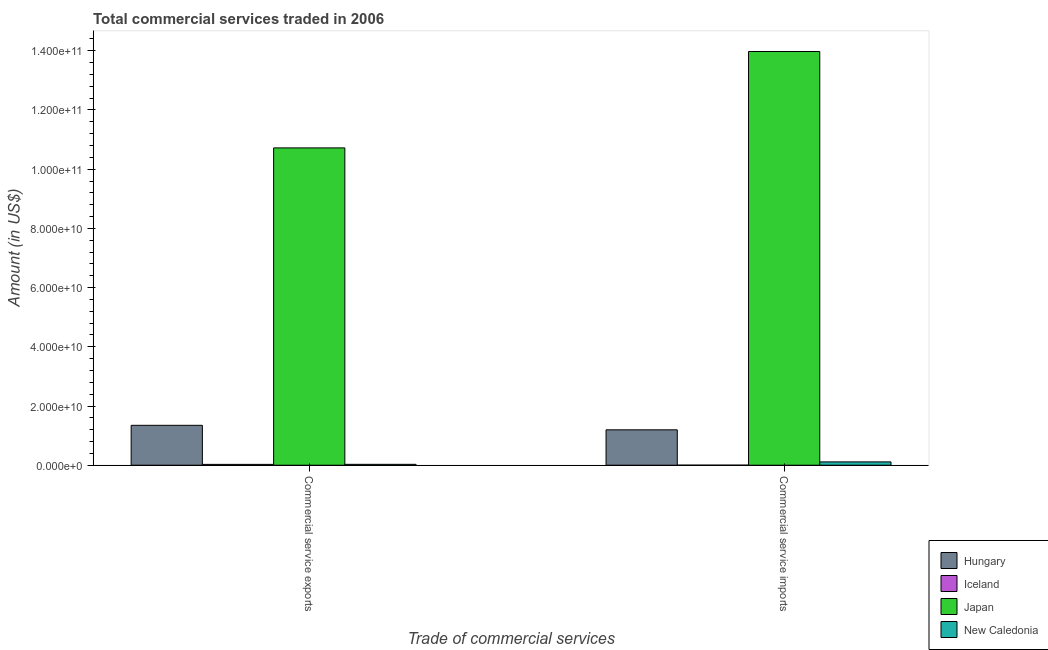How many bars are there on the 2nd tick from the left?
Provide a short and direct response. 4. What is the label of the 2nd group of bars from the left?
Keep it short and to the point. Commercial service imports. What is the amount of commercial service imports in Iceland?
Your answer should be very brief. 8.55e+06. Across all countries, what is the maximum amount of commercial service imports?
Provide a short and direct response. 1.40e+11. Across all countries, what is the minimum amount of commercial service imports?
Provide a succinct answer. 8.55e+06. What is the total amount of commercial service imports in the graph?
Offer a terse response. 1.53e+11. What is the difference between the amount of commercial service imports in Hungary and that in Iceland?
Your answer should be very brief. 1.19e+1. What is the difference between the amount of commercial service exports in Japan and the amount of commercial service imports in Hungary?
Keep it short and to the point. 9.52e+1. What is the average amount of commercial service exports per country?
Make the answer very short. 3.03e+1. What is the difference between the amount of commercial service exports and amount of commercial service imports in Japan?
Offer a terse response. -3.26e+1. In how many countries, is the amount of commercial service imports greater than 36000000000 US$?
Provide a succinct answer. 1. What is the ratio of the amount of commercial service exports in Iceland to that in New Caledonia?
Offer a terse response. 0.95. Is the amount of commercial service exports in New Caledonia less than that in Hungary?
Provide a short and direct response. Yes. In how many countries, is the amount of commercial service exports greater than the average amount of commercial service exports taken over all countries?
Provide a succinct answer. 1. What does the 3rd bar from the right in Commercial service imports represents?
Offer a very short reply. Iceland. How many countries are there in the graph?
Offer a terse response. 4. What is the difference between two consecutive major ticks on the Y-axis?
Your response must be concise. 2.00e+1. Are the values on the major ticks of Y-axis written in scientific E-notation?
Provide a short and direct response. Yes. Does the graph contain any zero values?
Your answer should be compact. No. How are the legend labels stacked?
Ensure brevity in your answer.  Vertical. What is the title of the graph?
Offer a terse response. Total commercial services traded in 2006. Does "Vanuatu" appear as one of the legend labels in the graph?
Your answer should be compact. No. What is the label or title of the X-axis?
Make the answer very short. Trade of commercial services. What is the label or title of the Y-axis?
Your answer should be very brief. Amount (in US$). What is the Amount (in US$) in Hungary in Commercial service exports?
Your answer should be very brief. 1.35e+1. What is the Amount (in US$) in Iceland in Commercial service exports?
Your answer should be compact. 2.80e+08. What is the Amount (in US$) of Japan in Commercial service exports?
Give a very brief answer. 1.07e+11. What is the Amount (in US$) of New Caledonia in Commercial service exports?
Give a very brief answer. 2.96e+08. What is the Amount (in US$) of Hungary in Commercial service imports?
Provide a short and direct response. 1.20e+1. What is the Amount (in US$) in Iceland in Commercial service imports?
Provide a succinct answer. 8.55e+06. What is the Amount (in US$) of Japan in Commercial service imports?
Your response must be concise. 1.40e+11. What is the Amount (in US$) of New Caledonia in Commercial service imports?
Your answer should be very brief. 1.12e+09. Across all Trade of commercial services, what is the maximum Amount (in US$) in Hungary?
Make the answer very short. 1.35e+1. Across all Trade of commercial services, what is the maximum Amount (in US$) of Iceland?
Offer a terse response. 2.80e+08. Across all Trade of commercial services, what is the maximum Amount (in US$) of Japan?
Offer a terse response. 1.40e+11. Across all Trade of commercial services, what is the maximum Amount (in US$) in New Caledonia?
Offer a very short reply. 1.12e+09. Across all Trade of commercial services, what is the minimum Amount (in US$) in Hungary?
Keep it short and to the point. 1.20e+1. Across all Trade of commercial services, what is the minimum Amount (in US$) in Iceland?
Ensure brevity in your answer.  8.55e+06. Across all Trade of commercial services, what is the minimum Amount (in US$) of Japan?
Make the answer very short. 1.07e+11. Across all Trade of commercial services, what is the minimum Amount (in US$) in New Caledonia?
Your response must be concise. 2.96e+08. What is the total Amount (in US$) of Hungary in the graph?
Provide a short and direct response. 2.54e+1. What is the total Amount (in US$) of Iceland in the graph?
Make the answer very short. 2.88e+08. What is the total Amount (in US$) in Japan in the graph?
Your answer should be very brief. 2.47e+11. What is the total Amount (in US$) of New Caledonia in the graph?
Make the answer very short. 1.41e+09. What is the difference between the Amount (in US$) in Hungary in Commercial service exports and that in Commercial service imports?
Give a very brief answer. 1.52e+09. What is the difference between the Amount (in US$) in Iceland in Commercial service exports and that in Commercial service imports?
Your answer should be very brief. 2.71e+08. What is the difference between the Amount (in US$) of Japan in Commercial service exports and that in Commercial service imports?
Provide a short and direct response. -3.26e+1. What is the difference between the Amount (in US$) in New Caledonia in Commercial service exports and that in Commercial service imports?
Your response must be concise. -8.24e+08. What is the difference between the Amount (in US$) of Hungary in Commercial service exports and the Amount (in US$) of Iceland in Commercial service imports?
Provide a short and direct response. 1.35e+1. What is the difference between the Amount (in US$) in Hungary in Commercial service exports and the Amount (in US$) in Japan in Commercial service imports?
Your answer should be very brief. -1.26e+11. What is the difference between the Amount (in US$) in Hungary in Commercial service exports and the Amount (in US$) in New Caledonia in Commercial service imports?
Make the answer very short. 1.24e+1. What is the difference between the Amount (in US$) in Iceland in Commercial service exports and the Amount (in US$) in Japan in Commercial service imports?
Provide a succinct answer. -1.39e+11. What is the difference between the Amount (in US$) in Iceland in Commercial service exports and the Amount (in US$) in New Caledonia in Commercial service imports?
Ensure brevity in your answer.  -8.39e+08. What is the difference between the Amount (in US$) of Japan in Commercial service exports and the Amount (in US$) of New Caledonia in Commercial service imports?
Your response must be concise. 1.06e+11. What is the average Amount (in US$) of Hungary per Trade of commercial services?
Provide a short and direct response. 1.27e+1. What is the average Amount (in US$) in Iceland per Trade of commercial services?
Offer a very short reply. 1.44e+08. What is the average Amount (in US$) of Japan per Trade of commercial services?
Ensure brevity in your answer.  1.23e+11. What is the average Amount (in US$) in New Caledonia per Trade of commercial services?
Your response must be concise. 7.07e+08. What is the difference between the Amount (in US$) of Hungary and Amount (in US$) of Iceland in Commercial service exports?
Provide a succinct answer. 1.32e+1. What is the difference between the Amount (in US$) of Hungary and Amount (in US$) of Japan in Commercial service exports?
Ensure brevity in your answer.  -9.37e+1. What is the difference between the Amount (in US$) in Hungary and Amount (in US$) in New Caledonia in Commercial service exports?
Give a very brief answer. 1.32e+1. What is the difference between the Amount (in US$) in Iceland and Amount (in US$) in Japan in Commercial service exports?
Offer a very short reply. -1.07e+11. What is the difference between the Amount (in US$) of Iceland and Amount (in US$) of New Caledonia in Commercial service exports?
Provide a short and direct response. -1.57e+07. What is the difference between the Amount (in US$) of Japan and Amount (in US$) of New Caledonia in Commercial service exports?
Your response must be concise. 1.07e+11. What is the difference between the Amount (in US$) of Hungary and Amount (in US$) of Iceland in Commercial service imports?
Your answer should be compact. 1.19e+1. What is the difference between the Amount (in US$) of Hungary and Amount (in US$) of Japan in Commercial service imports?
Your response must be concise. -1.28e+11. What is the difference between the Amount (in US$) of Hungary and Amount (in US$) of New Caledonia in Commercial service imports?
Keep it short and to the point. 1.08e+1. What is the difference between the Amount (in US$) of Iceland and Amount (in US$) of Japan in Commercial service imports?
Make the answer very short. -1.40e+11. What is the difference between the Amount (in US$) in Iceland and Amount (in US$) in New Caledonia in Commercial service imports?
Your response must be concise. -1.11e+09. What is the difference between the Amount (in US$) of Japan and Amount (in US$) of New Caledonia in Commercial service imports?
Ensure brevity in your answer.  1.39e+11. What is the ratio of the Amount (in US$) in Hungary in Commercial service exports to that in Commercial service imports?
Provide a short and direct response. 1.13. What is the ratio of the Amount (in US$) in Iceland in Commercial service exports to that in Commercial service imports?
Ensure brevity in your answer.  32.74. What is the ratio of the Amount (in US$) in Japan in Commercial service exports to that in Commercial service imports?
Keep it short and to the point. 0.77. What is the ratio of the Amount (in US$) of New Caledonia in Commercial service exports to that in Commercial service imports?
Give a very brief answer. 0.26. What is the difference between the highest and the second highest Amount (in US$) in Hungary?
Provide a succinct answer. 1.52e+09. What is the difference between the highest and the second highest Amount (in US$) in Iceland?
Your answer should be compact. 2.71e+08. What is the difference between the highest and the second highest Amount (in US$) of Japan?
Your answer should be compact. 3.26e+1. What is the difference between the highest and the second highest Amount (in US$) in New Caledonia?
Make the answer very short. 8.24e+08. What is the difference between the highest and the lowest Amount (in US$) in Hungary?
Offer a very short reply. 1.52e+09. What is the difference between the highest and the lowest Amount (in US$) in Iceland?
Give a very brief answer. 2.71e+08. What is the difference between the highest and the lowest Amount (in US$) in Japan?
Offer a terse response. 3.26e+1. What is the difference between the highest and the lowest Amount (in US$) in New Caledonia?
Keep it short and to the point. 8.24e+08. 